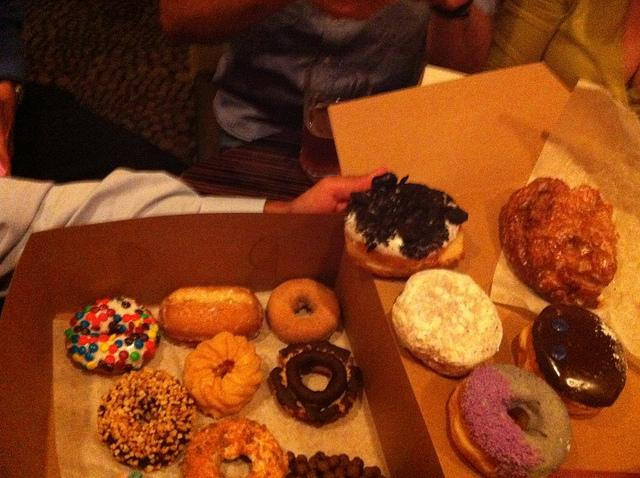What unhealthy ingredient does this food contain the most?

Choices:
A) flour
B) sugar
C) nuts
D) chocolate sugar 